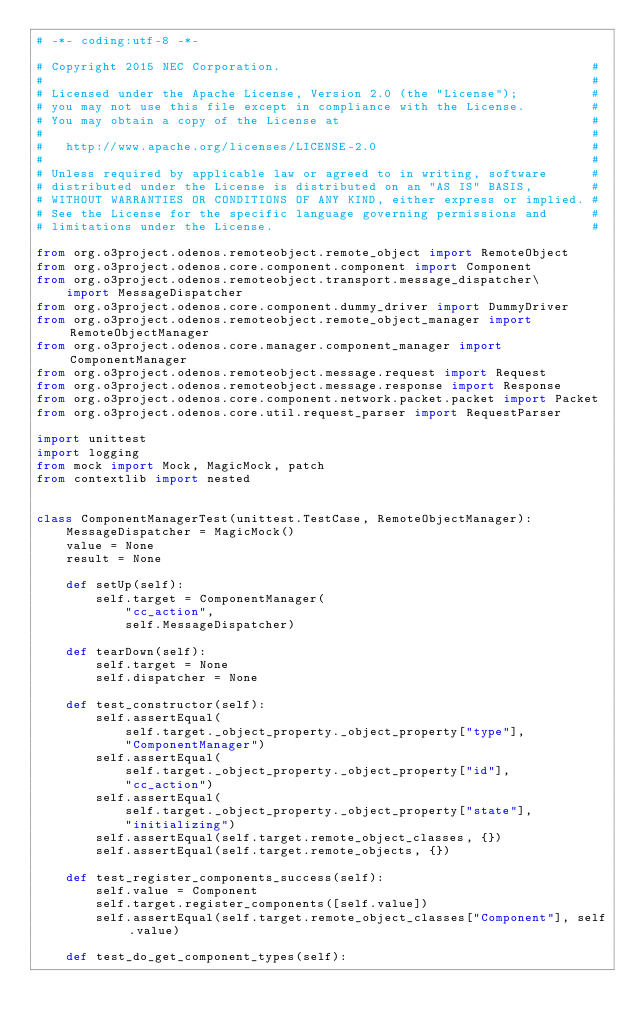<code> <loc_0><loc_0><loc_500><loc_500><_Python_># -*- coding:utf-8 -*-

# Copyright 2015 NEC Corporation.                                          #
#                                                                          #
# Licensed under the Apache License, Version 2.0 (the "License");          #
# you may not use this file except in compliance with the License.         #
# You may obtain a copy of the License at                                  #
#                                                                          #
#   http://www.apache.org/licenses/LICENSE-2.0                             #
#                                                                          #
# Unless required by applicable law or agreed to in writing, software      #
# distributed under the License is distributed on an "AS IS" BASIS,        #
# WITHOUT WARRANTIES OR CONDITIONS OF ANY KIND, either express or implied. #
# See the License for the specific language governing permissions and      #
# limitations under the License.                                           #

from org.o3project.odenos.remoteobject.remote_object import RemoteObject
from org.o3project.odenos.core.component.component import Component
from org.o3project.odenos.remoteobject.transport.message_dispatcher\
    import MessageDispatcher
from org.o3project.odenos.core.component.dummy_driver import DummyDriver
from org.o3project.odenos.remoteobject.remote_object_manager import RemoteObjectManager
from org.o3project.odenos.core.manager.component_manager import ComponentManager 
from org.o3project.odenos.remoteobject.message.request import Request
from org.o3project.odenos.remoteobject.message.response import Response
from org.o3project.odenos.core.component.network.packet.packet import Packet
from org.o3project.odenos.core.util.request_parser import RequestParser

import unittest
import logging
from mock import Mock, MagicMock, patch
from contextlib import nested


class ComponentManagerTest(unittest.TestCase, RemoteObjectManager):
    MessageDispatcher = MagicMock()
    value = None
    result = None

    def setUp(self):
        self.target = ComponentManager(
            "cc_action",
            self.MessageDispatcher)

    def tearDown(self):
        self.target = None
        self.dispatcher = None

    def test_constructor(self):
        self.assertEqual(
            self.target._object_property._object_property["type"],
            "ComponentManager")
        self.assertEqual(
            self.target._object_property._object_property["id"],
            "cc_action")
        self.assertEqual(
            self.target._object_property._object_property["state"],
            "initializing")
        self.assertEqual(self.target.remote_object_classes, {})
        self.assertEqual(self.target.remote_objects, {})

    def test_register_components_success(self):
        self.value = Component 
        self.target.register_components([self.value])
        self.assertEqual(self.target.remote_object_classes["Component"], self.value) 

    def test_do_get_component_types(self):</code> 